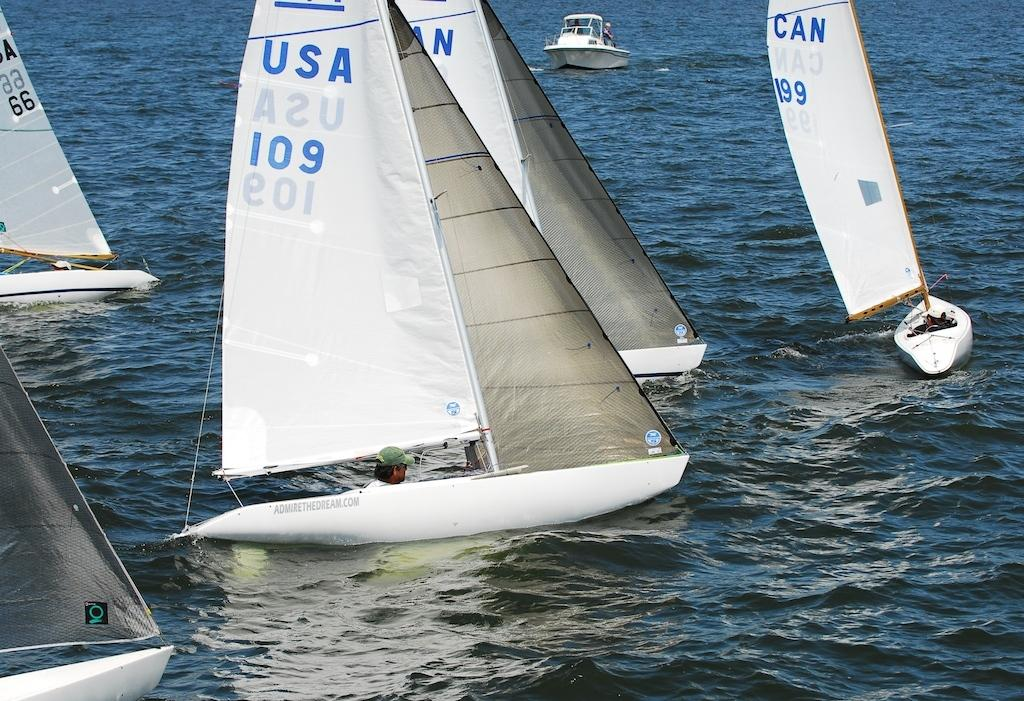What can be seen in the image that is used for transportation on water? There are boats in the image that are used for transportation on water. What is the boats' current state in the image? The boats are floating on water in the image. Are there any passengers in the boats? Yes, there are people in the boats. What type of gold can be seen on the insect in the image? There is no insect or gold present in the image; it only features boats floating on water with people in them. 